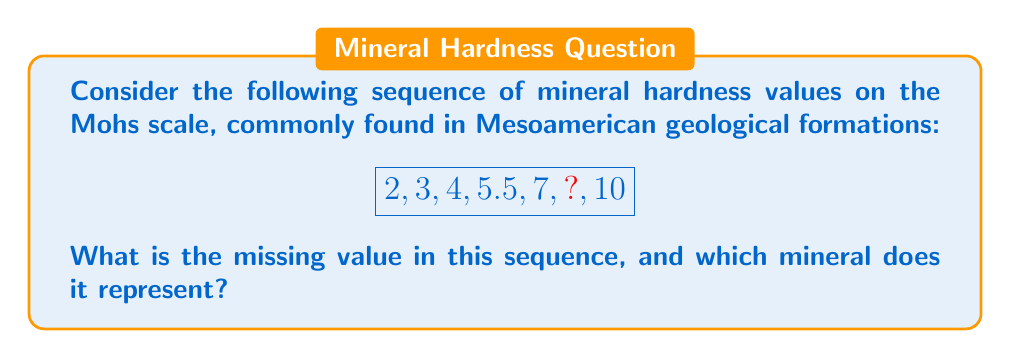Provide a solution to this math problem. To solve this problem, let's follow these steps:

1) First, identify the pattern in the sequence:
   The difference between each consecutive pair of numbers increases by 0.5:
   $3 - 2 = 1$
   $4 - 3 = 1.5$
   $5.5 - 4 = 1.5$
   $7 - 5.5 = 1.5$

2) Following this pattern, the next difference should be 2:
   $? - 7 = 2$

3) Therefore, the missing value is:
   $7 + 2 = 9$

4) Now, let's match this to the Mohs scale of mineral hardness:
   2 - Gypsum
   3 - Calcite
   4 - Fluorite
   5.5 - Apatite
   7 - Quartz
   9 - Corundum
   10 - Diamond

5) The mineral with a hardness of 9 on the Mohs scale is Corundum.

This sequence is particularly relevant to Mesoamerican geology, as these minerals are often found in the diverse geological formations of the region, from sedimentary rocks containing gypsum and calcite to igneous formations with quartz and occasionally, harder minerals like corundum.
Answer: 9 (Corundum) 